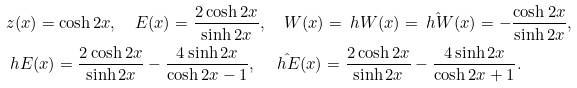<formula> <loc_0><loc_0><loc_500><loc_500>& z ( x ) = \cosh 2 x , \quad E ( x ) = \frac { 2 \cosh 2 x } { \sinh 2 x } , \quad W ( x ) = \ h W ( x ) = \hat { \ h W } ( x ) = - \frac { \cosh 2 x } { \sinh 2 x } , \\ & \ h E ( x ) = \frac { 2 \cosh 2 x } { \sinh 2 x } - \frac { 4 \sinh 2 x } { \cosh 2 x - 1 } , \quad \hat { \ h E } ( x ) = \frac { 2 \cosh 2 x } { \sinh 2 x } - \frac { 4 \sinh 2 x } { \cosh 2 x + 1 } .</formula> 